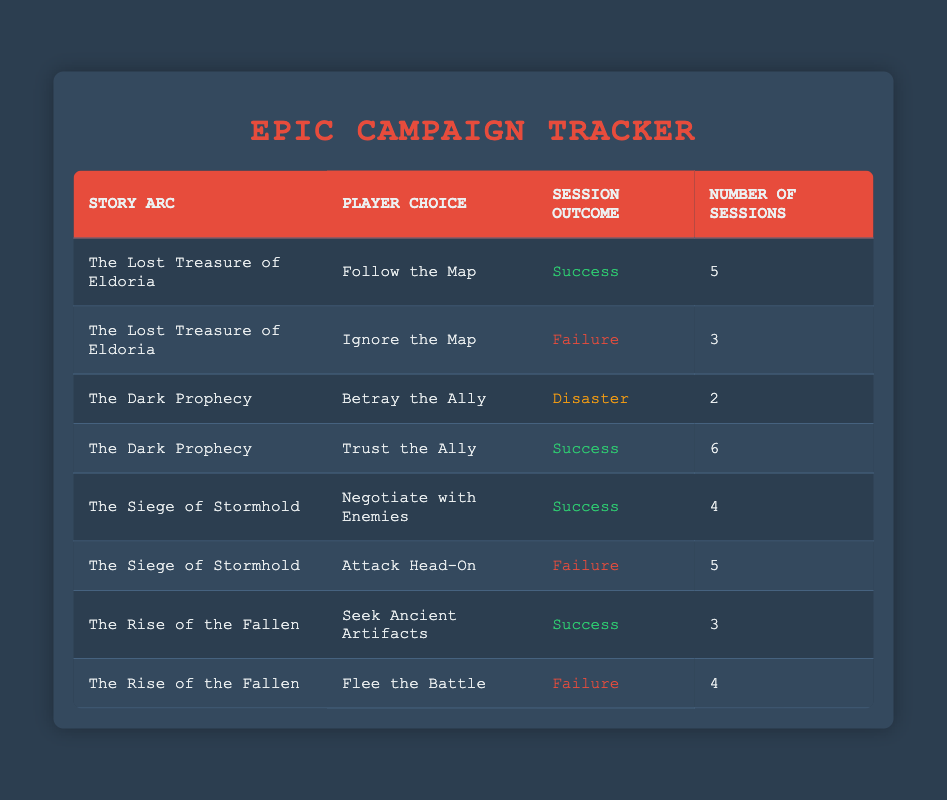What is the session outcome for the choice "Follow the Map" in "The Lost Treasure of Eldoria"? The table shows the outcome for this specific player choice and story arc. It indicates that the session outcome is classified as "Success."
Answer: Success How many sessions ended in failure for "The Siege of Stormhold"? By looking at the table, the row for "The Siege of Stormhold" with the choice "Attack Head-On" indicates that there are 5 sessions that ended in failure.
Answer: 5 Which story arc had the highest number of successful sessions? The session outcomes classified as "Success" are: "The Lost Treasure of Eldoria" (5 sessions), "The Dark Prophecy" (6 sessions), "The Siege of Stormhold" (4 sessions), and "The Rise of the Fallen" (3 sessions). The highest is from "The Dark Prophecy" with 6 successful sessions.
Answer: The Dark Prophecy Is it true that choosing to "Flee the Battle" in "The Rise of the Fallen" resulted in a disaster? The table indicates the outcome for this choice is "Failure," not "Disaster." Therefore, the statement is false.
Answer: False What is the total number of sessions across all story arcs that resulted in success? Summing the successful sessions from the table: 5 (Eldoria) + 6 (Dark Prophecy) + 4 (Siege of Stormhold) + 3 (Rise of the Fallen) = 18 sessions.
Answer: 18 How many sessions resulted in a disaster versus a failure across all story arcs? Counting from the table, there are 2 sessions resulting in a disaster (Betray the Ally) and 12 sessions resulting in failure (3 from Eldoria, 5 from Siege, and 4 from Rise of the Fallen).
Answer: Disaster: 2, Failure: 12 What is the average number of sessions for the player choice "Trust the Ally"? From the table, this choice has 6 sessions. Since it's a single data point, the average equals the number of sessions for this choice, which is simply 6/1 = 6.
Answer: 6 Which player choice had a session outcome of disaster? The only player choice that resulted in a session outcome of disaster is "Betray the Ally" in "The Dark Prophecy," as indicated in the table.
Answer: Betray the Ally 